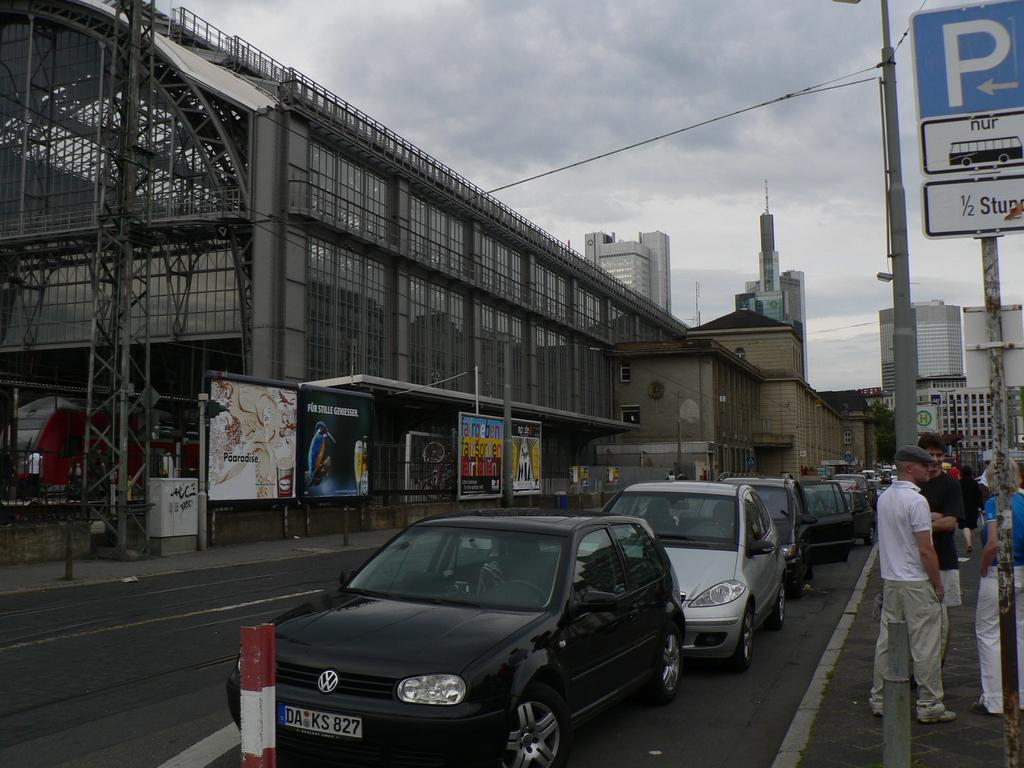What is the main feature of the image? The main feature of the image is a road. What can be seen traveling on the road? There are cars in the image. Are there any people present in the image? Yes, there are persons in the image. What other structures can be seen in the image? There are sign boards, street lights, wires, buildings, and advertisements in the image. What is visible in the sky in the image? The sky is visible in the image, and there are clouds present. How does the goose feel about the effect of the advertisements on the environment in the image? There is no goose present in the image, and therefore no such feelings or effects can be observed. 